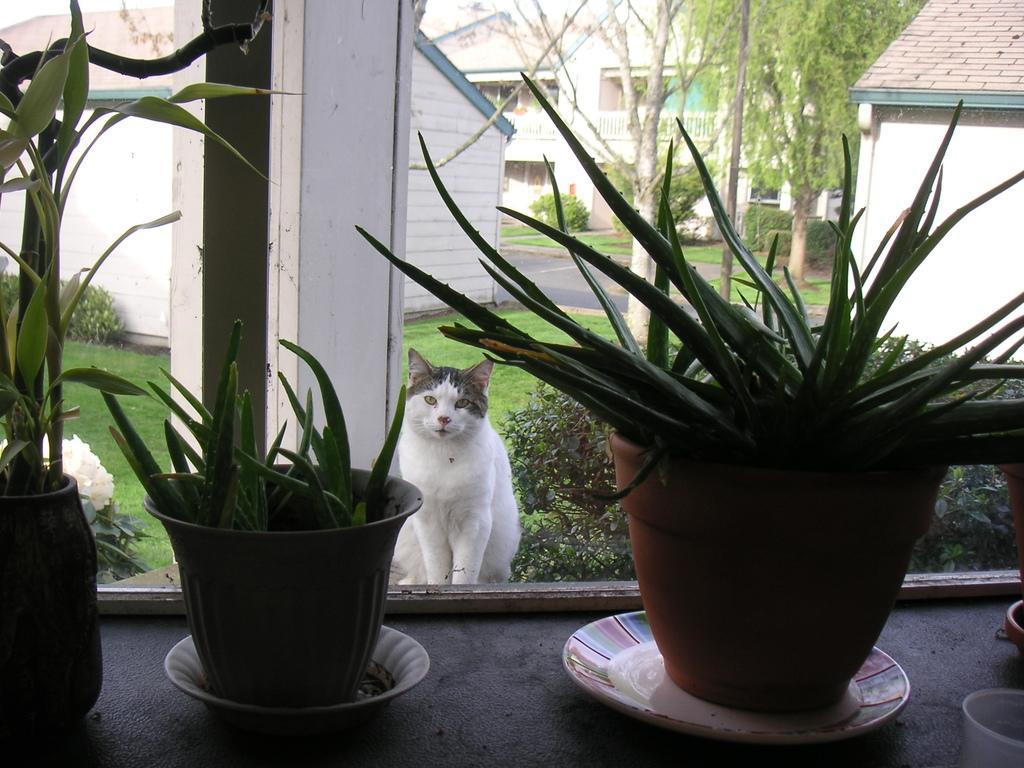In one or two sentences, can you explain what this image depicts? In this image we can see three pots. Behind one cat is there. Background of the image tree, plants and houses are present. 